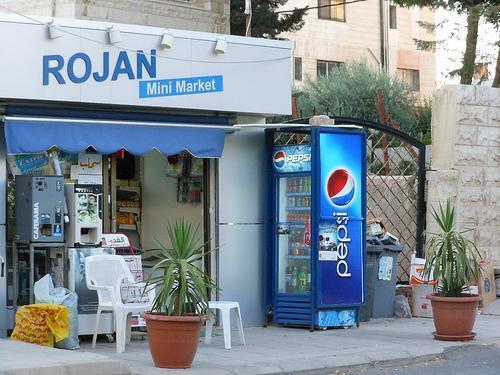How many soda machines?
Give a very brief answer. 1. 